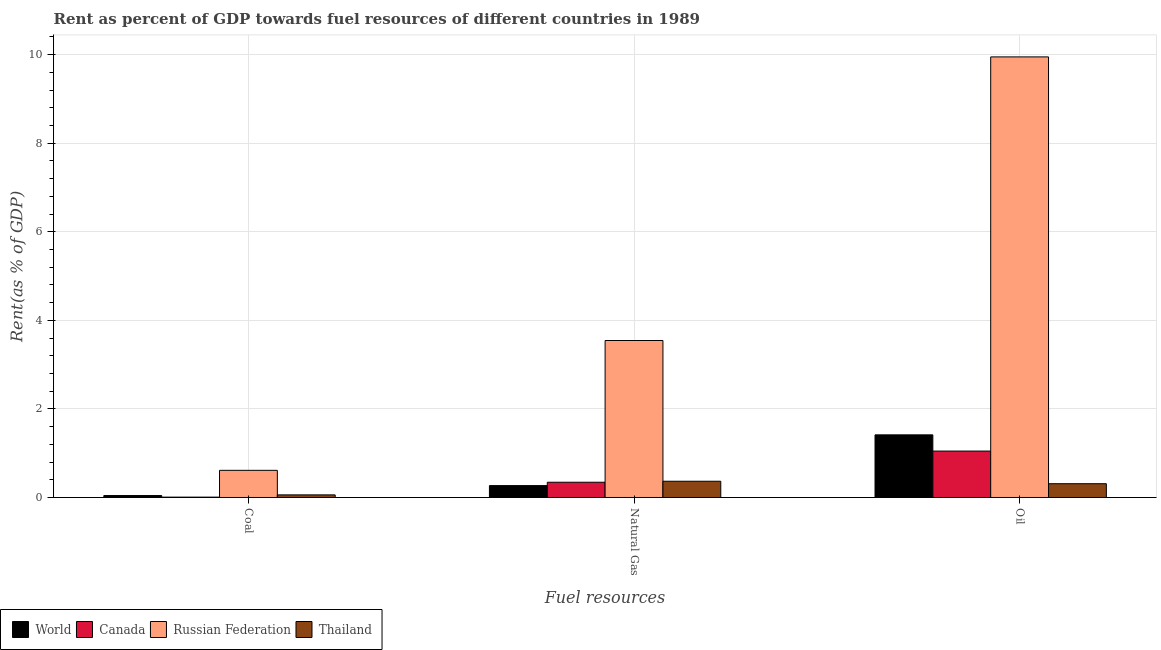How many different coloured bars are there?
Keep it short and to the point. 4. Are the number of bars per tick equal to the number of legend labels?
Offer a terse response. Yes. How many bars are there on the 2nd tick from the left?
Your answer should be very brief. 4. How many bars are there on the 3rd tick from the right?
Ensure brevity in your answer.  4. What is the label of the 1st group of bars from the left?
Keep it short and to the point. Coal. What is the rent towards oil in World?
Give a very brief answer. 1.41. Across all countries, what is the maximum rent towards natural gas?
Offer a terse response. 3.55. Across all countries, what is the minimum rent towards coal?
Keep it short and to the point. 0.01. In which country was the rent towards oil maximum?
Offer a very short reply. Russian Federation. In which country was the rent towards oil minimum?
Your response must be concise. Thailand. What is the total rent towards coal in the graph?
Your answer should be very brief. 0.72. What is the difference between the rent towards natural gas in World and that in Thailand?
Your response must be concise. -0.1. What is the difference between the rent towards coal in Thailand and the rent towards natural gas in Russian Federation?
Ensure brevity in your answer.  -3.49. What is the average rent towards oil per country?
Keep it short and to the point. 3.18. What is the difference between the rent towards coal and rent towards natural gas in Thailand?
Your response must be concise. -0.31. What is the ratio of the rent towards oil in Thailand to that in Russian Federation?
Provide a succinct answer. 0.03. Is the difference between the rent towards oil in Canada and Thailand greater than the difference between the rent towards natural gas in Canada and Thailand?
Your answer should be very brief. Yes. What is the difference between the highest and the second highest rent towards coal?
Provide a succinct answer. 0.55. What is the difference between the highest and the lowest rent towards natural gas?
Offer a very short reply. 3.28. Is the sum of the rent towards natural gas in Thailand and World greater than the maximum rent towards oil across all countries?
Keep it short and to the point. No. What does the 4th bar from the left in Coal represents?
Your answer should be compact. Thailand. What does the 2nd bar from the right in Natural Gas represents?
Provide a short and direct response. Russian Federation. How many bars are there?
Keep it short and to the point. 12. How many countries are there in the graph?
Provide a short and direct response. 4. Are the values on the major ticks of Y-axis written in scientific E-notation?
Your answer should be compact. No. Does the graph contain grids?
Your answer should be very brief. Yes. How are the legend labels stacked?
Ensure brevity in your answer.  Horizontal. What is the title of the graph?
Make the answer very short. Rent as percent of GDP towards fuel resources of different countries in 1989. Does "South Africa" appear as one of the legend labels in the graph?
Ensure brevity in your answer.  No. What is the label or title of the X-axis?
Keep it short and to the point. Fuel resources. What is the label or title of the Y-axis?
Provide a short and direct response. Rent(as % of GDP). What is the Rent(as % of GDP) of World in Coal?
Provide a short and direct response. 0.04. What is the Rent(as % of GDP) of Canada in Coal?
Give a very brief answer. 0.01. What is the Rent(as % of GDP) of Russian Federation in Coal?
Offer a very short reply. 0.61. What is the Rent(as % of GDP) in Thailand in Coal?
Your response must be concise. 0.06. What is the Rent(as % of GDP) in World in Natural Gas?
Keep it short and to the point. 0.27. What is the Rent(as % of GDP) of Canada in Natural Gas?
Your answer should be very brief. 0.34. What is the Rent(as % of GDP) of Russian Federation in Natural Gas?
Your response must be concise. 3.55. What is the Rent(as % of GDP) in Thailand in Natural Gas?
Your answer should be compact. 0.37. What is the Rent(as % of GDP) in World in Oil?
Make the answer very short. 1.41. What is the Rent(as % of GDP) of Canada in Oil?
Provide a succinct answer. 1.05. What is the Rent(as % of GDP) in Russian Federation in Oil?
Give a very brief answer. 9.95. What is the Rent(as % of GDP) of Thailand in Oil?
Ensure brevity in your answer.  0.31. Across all Fuel resources, what is the maximum Rent(as % of GDP) of World?
Offer a very short reply. 1.41. Across all Fuel resources, what is the maximum Rent(as % of GDP) of Canada?
Make the answer very short. 1.05. Across all Fuel resources, what is the maximum Rent(as % of GDP) of Russian Federation?
Provide a succinct answer. 9.95. Across all Fuel resources, what is the maximum Rent(as % of GDP) of Thailand?
Give a very brief answer. 0.37. Across all Fuel resources, what is the minimum Rent(as % of GDP) in World?
Your answer should be very brief. 0.04. Across all Fuel resources, what is the minimum Rent(as % of GDP) of Canada?
Ensure brevity in your answer.  0.01. Across all Fuel resources, what is the minimum Rent(as % of GDP) of Russian Federation?
Offer a terse response. 0.61. Across all Fuel resources, what is the minimum Rent(as % of GDP) of Thailand?
Provide a short and direct response. 0.06. What is the total Rent(as % of GDP) of World in the graph?
Offer a terse response. 1.73. What is the total Rent(as % of GDP) of Canada in the graph?
Your response must be concise. 1.4. What is the total Rent(as % of GDP) of Russian Federation in the graph?
Keep it short and to the point. 14.11. What is the total Rent(as % of GDP) in Thailand in the graph?
Provide a succinct answer. 0.74. What is the difference between the Rent(as % of GDP) in World in Coal and that in Natural Gas?
Your answer should be compact. -0.22. What is the difference between the Rent(as % of GDP) of Canada in Coal and that in Natural Gas?
Your answer should be very brief. -0.34. What is the difference between the Rent(as % of GDP) in Russian Federation in Coal and that in Natural Gas?
Make the answer very short. -2.93. What is the difference between the Rent(as % of GDP) in Thailand in Coal and that in Natural Gas?
Make the answer very short. -0.31. What is the difference between the Rent(as % of GDP) of World in Coal and that in Oil?
Offer a very short reply. -1.37. What is the difference between the Rent(as % of GDP) in Canada in Coal and that in Oil?
Keep it short and to the point. -1.04. What is the difference between the Rent(as % of GDP) in Russian Federation in Coal and that in Oil?
Provide a succinct answer. -9.34. What is the difference between the Rent(as % of GDP) of Thailand in Coal and that in Oil?
Offer a terse response. -0.25. What is the difference between the Rent(as % of GDP) in World in Natural Gas and that in Oil?
Provide a short and direct response. -1.15. What is the difference between the Rent(as % of GDP) of Canada in Natural Gas and that in Oil?
Keep it short and to the point. -0.7. What is the difference between the Rent(as % of GDP) of Russian Federation in Natural Gas and that in Oil?
Make the answer very short. -6.41. What is the difference between the Rent(as % of GDP) of Thailand in Natural Gas and that in Oil?
Give a very brief answer. 0.06. What is the difference between the Rent(as % of GDP) of World in Coal and the Rent(as % of GDP) of Canada in Natural Gas?
Your answer should be very brief. -0.3. What is the difference between the Rent(as % of GDP) of World in Coal and the Rent(as % of GDP) of Russian Federation in Natural Gas?
Your response must be concise. -3.5. What is the difference between the Rent(as % of GDP) of World in Coal and the Rent(as % of GDP) of Thailand in Natural Gas?
Provide a succinct answer. -0.32. What is the difference between the Rent(as % of GDP) in Canada in Coal and the Rent(as % of GDP) in Russian Federation in Natural Gas?
Your response must be concise. -3.54. What is the difference between the Rent(as % of GDP) of Canada in Coal and the Rent(as % of GDP) of Thailand in Natural Gas?
Give a very brief answer. -0.36. What is the difference between the Rent(as % of GDP) in Russian Federation in Coal and the Rent(as % of GDP) in Thailand in Natural Gas?
Your response must be concise. 0.25. What is the difference between the Rent(as % of GDP) in World in Coal and the Rent(as % of GDP) in Canada in Oil?
Provide a short and direct response. -1. What is the difference between the Rent(as % of GDP) of World in Coal and the Rent(as % of GDP) of Russian Federation in Oil?
Your response must be concise. -9.91. What is the difference between the Rent(as % of GDP) in World in Coal and the Rent(as % of GDP) in Thailand in Oil?
Your answer should be compact. -0.27. What is the difference between the Rent(as % of GDP) of Canada in Coal and the Rent(as % of GDP) of Russian Federation in Oil?
Make the answer very short. -9.94. What is the difference between the Rent(as % of GDP) in Canada in Coal and the Rent(as % of GDP) in Thailand in Oil?
Provide a short and direct response. -0.3. What is the difference between the Rent(as % of GDP) in Russian Federation in Coal and the Rent(as % of GDP) in Thailand in Oil?
Provide a short and direct response. 0.3. What is the difference between the Rent(as % of GDP) of World in Natural Gas and the Rent(as % of GDP) of Canada in Oil?
Ensure brevity in your answer.  -0.78. What is the difference between the Rent(as % of GDP) of World in Natural Gas and the Rent(as % of GDP) of Russian Federation in Oil?
Keep it short and to the point. -9.68. What is the difference between the Rent(as % of GDP) of World in Natural Gas and the Rent(as % of GDP) of Thailand in Oil?
Ensure brevity in your answer.  -0.04. What is the difference between the Rent(as % of GDP) of Canada in Natural Gas and the Rent(as % of GDP) of Russian Federation in Oil?
Make the answer very short. -9.61. What is the difference between the Rent(as % of GDP) in Canada in Natural Gas and the Rent(as % of GDP) in Thailand in Oil?
Offer a very short reply. 0.03. What is the difference between the Rent(as % of GDP) of Russian Federation in Natural Gas and the Rent(as % of GDP) of Thailand in Oil?
Offer a terse response. 3.23. What is the average Rent(as % of GDP) of World per Fuel resources?
Your answer should be very brief. 0.58. What is the average Rent(as % of GDP) in Canada per Fuel resources?
Provide a short and direct response. 0.47. What is the average Rent(as % of GDP) in Russian Federation per Fuel resources?
Make the answer very short. 4.7. What is the average Rent(as % of GDP) of Thailand per Fuel resources?
Offer a terse response. 0.25. What is the difference between the Rent(as % of GDP) of World and Rent(as % of GDP) of Canada in Coal?
Provide a short and direct response. 0.04. What is the difference between the Rent(as % of GDP) of World and Rent(as % of GDP) of Russian Federation in Coal?
Your answer should be compact. -0.57. What is the difference between the Rent(as % of GDP) of World and Rent(as % of GDP) of Thailand in Coal?
Ensure brevity in your answer.  -0.01. What is the difference between the Rent(as % of GDP) in Canada and Rent(as % of GDP) in Russian Federation in Coal?
Make the answer very short. -0.61. What is the difference between the Rent(as % of GDP) in Canada and Rent(as % of GDP) in Thailand in Coal?
Provide a succinct answer. -0.05. What is the difference between the Rent(as % of GDP) in Russian Federation and Rent(as % of GDP) in Thailand in Coal?
Offer a very short reply. 0.55. What is the difference between the Rent(as % of GDP) of World and Rent(as % of GDP) of Canada in Natural Gas?
Offer a terse response. -0.08. What is the difference between the Rent(as % of GDP) of World and Rent(as % of GDP) of Russian Federation in Natural Gas?
Ensure brevity in your answer.  -3.28. What is the difference between the Rent(as % of GDP) in World and Rent(as % of GDP) in Thailand in Natural Gas?
Make the answer very short. -0.1. What is the difference between the Rent(as % of GDP) of Canada and Rent(as % of GDP) of Russian Federation in Natural Gas?
Offer a terse response. -3.2. What is the difference between the Rent(as % of GDP) of Canada and Rent(as % of GDP) of Thailand in Natural Gas?
Ensure brevity in your answer.  -0.02. What is the difference between the Rent(as % of GDP) in Russian Federation and Rent(as % of GDP) in Thailand in Natural Gas?
Offer a very short reply. 3.18. What is the difference between the Rent(as % of GDP) of World and Rent(as % of GDP) of Canada in Oil?
Keep it short and to the point. 0.37. What is the difference between the Rent(as % of GDP) in World and Rent(as % of GDP) in Russian Federation in Oil?
Keep it short and to the point. -8.54. What is the difference between the Rent(as % of GDP) in World and Rent(as % of GDP) in Thailand in Oil?
Ensure brevity in your answer.  1.1. What is the difference between the Rent(as % of GDP) in Canada and Rent(as % of GDP) in Russian Federation in Oil?
Offer a very short reply. -8.9. What is the difference between the Rent(as % of GDP) of Canada and Rent(as % of GDP) of Thailand in Oil?
Your answer should be compact. 0.74. What is the difference between the Rent(as % of GDP) in Russian Federation and Rent(as % of GDP) in Thailand in Oil?
Give a very brief answer. 9.64. What is the ratio of the Rent(as % of GDP) in World in Coal to that in Natural Gas?
Give a very brief answer. 0.16. What is the ratio of the Rent(as % of GDP) of Canada in Coal to that in Natural Gas?
Give a very brief answer. 0.02. What is the ratio of the Rent(as % of GDP) in Russian Federation in Coal to that in Natural Gas?
Make the answer very short. 0.17. What is the ratio of the Rent(as % of GDP) of Thailand in Coal to that in Natural Gas?
Your response must be concise. 0.16. What is the ratio of the Rent(as % of GDP) in World in Coal to that in Oil?
Your answer should be very brief. 0.03. What is the ratio of the Rent(as % of GDP) in Canada in Coal to that in Oil?
Keep it short and to the point. 0.01. What is the ratio of the Rent(as % of GDP) in Russian Federation in Coal to that in Oil?
Offer a terse response. 0.06. What is the ratio of the Rent(as % of GDP) in Thailand in Coal to that in Oil?
Make the answer very short. 0.19. What is the ratio of the Rent(as % of GDP) of World in Natural Gas to that in Oil?
Ensure brevity in your answer.  0.19. What is the ratio of the Rent(as % of GDP) of Canada in Natural Gas to that in Oil?
Your answer should be compact. 0.33. What is the ratio of the Rent(as % of GDP) in Russian Federation in Natural Gas to that in Oil?
Make the answer very short. 0.36. What is the ratio of the Rent(as % of GDP) in Thailand in Natural Gas to that in Oil?
Provide a short and direct response. 1.18. What is the difference between the highest and the second highest Rent(as % of GDP) of World?
Keep it short and to the point. 1.15. What is the difference between the highest and the second highest Rent(as % of GDP) in Canada?
Keep it short and to the point. 0.7. What is the difference between the highest and the second highest Rent(as % of GDP) in Russian Federation?
Make the answer very short. 6.41. What is the difference between the highest and the second highest Rent(as % of GDP) of Thailand?
Offer a terse response. 0.06. What is the difference between the highest and the lowest Rent(as % of GDP) of World?
Ensure brevity in your answer.  1.37. What is the difference between the highest and the lowest Rent(as % of GDP) in Canada?
Your answer should be very brief. 1.04. What is the difference between the highest and the lowest Rent(as % of GDP) in Russian Federation?
Give a very brief answer. 9.34. What is the difference between the highest and the lowest Rent(as % of GDP) in Thailand?
Offer a terse response. 0.31. 